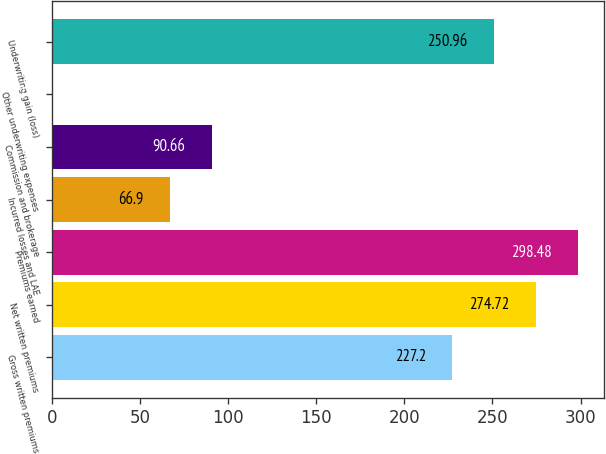<chart> <loc_0><loc_0><loc_500><loc_500><bar_chart><fcel>Gross written premiums<fcel>Net written premiums<fcel>Premiums earned<fcel>Incurred losses and LAE<fcel>Commission and brokerage<fcel>Other underwriting expenses<fcel>Underwriting gain (loss)<nl><fcel>227.2<fcel>274.72<fcel>298.48<fcel>66.9<fcel>90.66<fcel>0.2<fcel>250.96<nl></chart> 